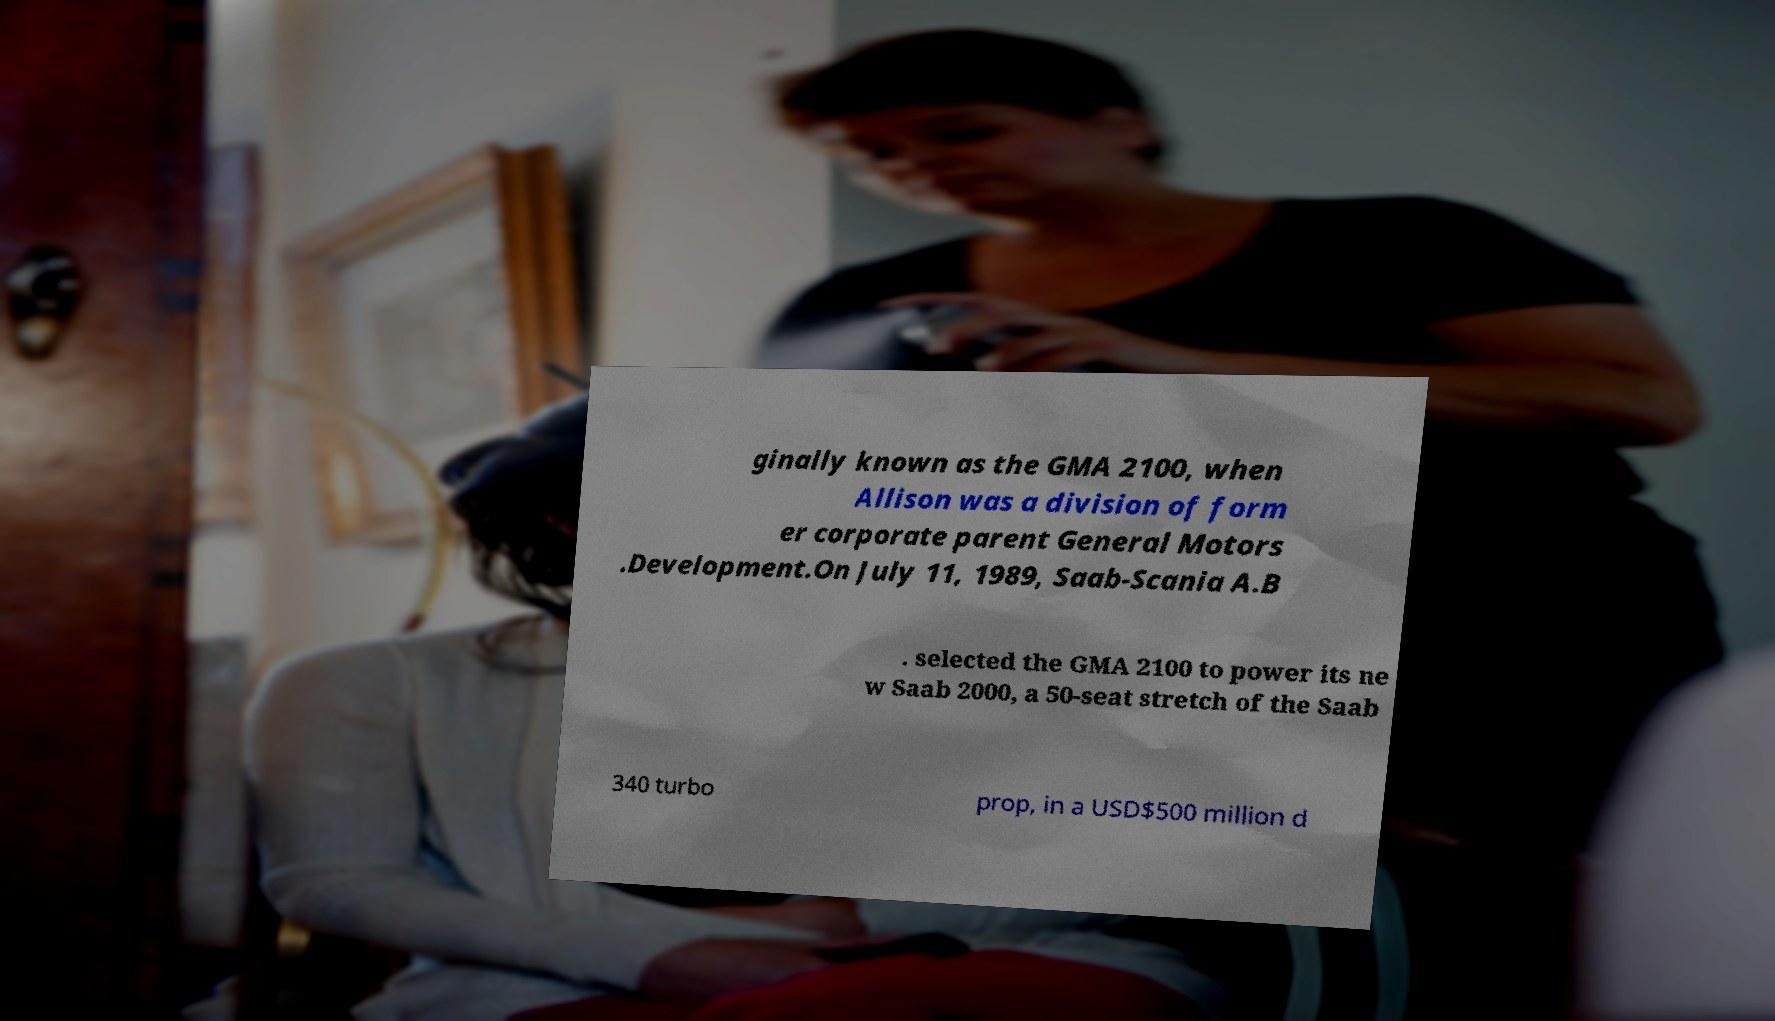Can you read and provide the text displayed in the image?This photo seems to have some interesting text. Can you extract and type it out for me? ginally known as the GMA 2100, when Allison was a division of form er corporate parent General Motors .Development.On July 11, 1989, Saab-Scania A.B . selected the GMA 2100 to power its ne w Saab 2000, a 50-seat stretch of the Saab 340 turbo prop, in a USD$500 million d 